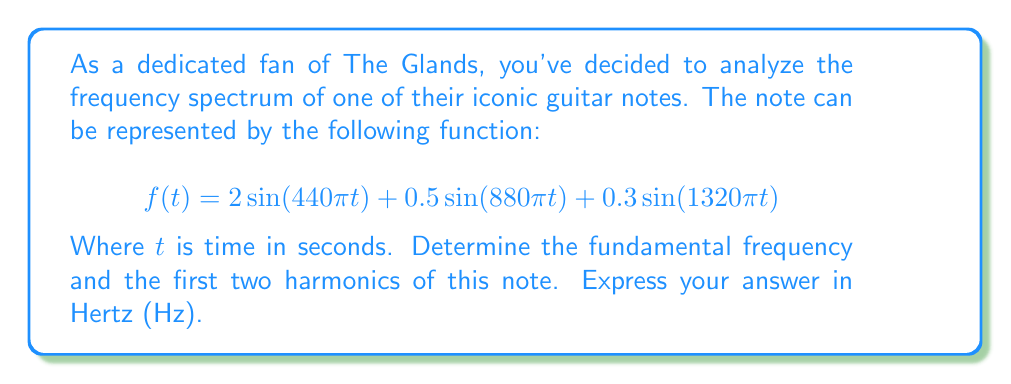Solve this math problem. To analyze the frequency spectrum of this musical note, we need to examine the Fourier series representation given by the function $f(t)$. Each term in the series corresponds to a different frequency component.

1) First, let's identify the general form of each term:
   $$A\sin(2\pi ft)$$
   Where $A$ is the amplitude and $f$ is the frequency in Hz.

2) Now, let's analyze each term in the given function:

   Term 1: $2\sin(440\pi t)$
   Comparing with the general form, we have:
   $2\pi f = 440\pi$
   $f = 220$ Hz

   Term 2: $0.5\sin(880\pi t)$
   $2\pi f = 880\pi$
   $f = 440$ Hz

   Term 3: $0.3\sin(1320\pi t)$
   $2\pi f = 1320\pi$
   $f = 660$ Hz

3) The fundamental frequency is the lowest frequency in the series, which is 220 Hz.

4) The harmonics are integer multiples of the fundamental frequency:
   - First harmonic (2nd overtone): $220 \times 2 = 440$ Hz
   - Second harmonic (3rd overtone): $220 \times 3 = 660$ Hz

These frequencies correspond exactly to the terms in our function, confirming our analysis.
Answer: Fundamental frequency: 220 Hz
First harmonic: 440 Hz
Second harmonic: 660 Hz 